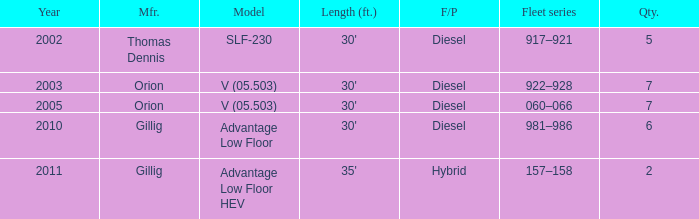Tell me the model with fuel or propulsion of diesel and orion manufacturer in 2005 V (05.503). 